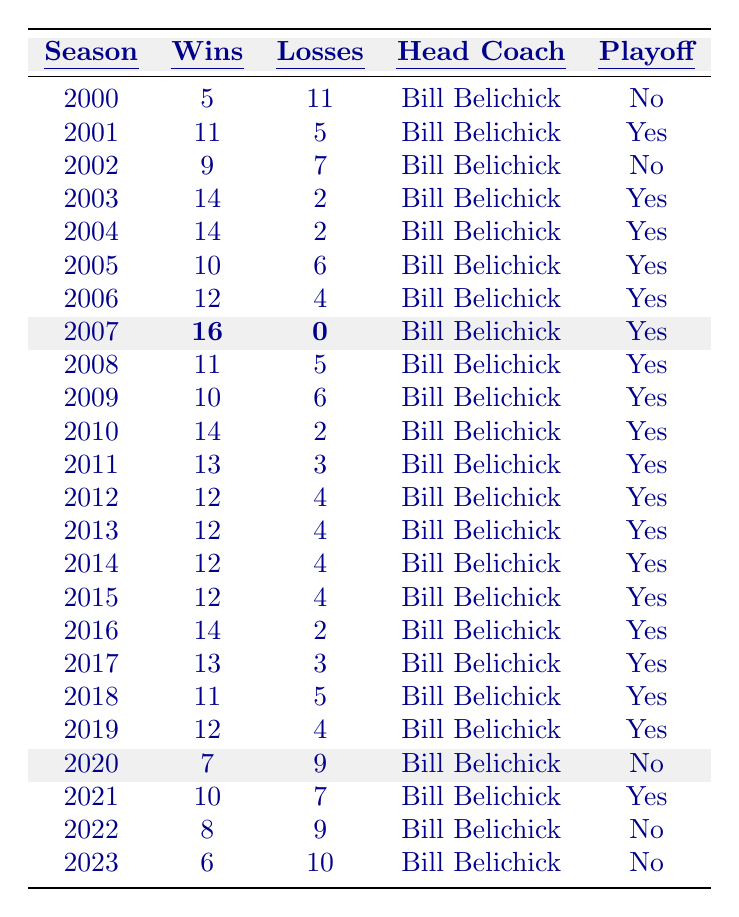What was the worst win-loss record for the Patriots during the 2000s? Reviewing the seasons from 2000 to 2009, the Patriots had their worst record in 2000 with 5 wins and 11 losses.
Answer: 5 wins, 11 losses How many seasons did the New England Patriots win 12 or more games? Counting the seasons where the wins are 12 or more, we find the following seasons: 2006, 2007, 2010, 2011, 2012, 2013, 2014, 2015, and 2016. This totals to 9 seasons.
Answer: 9 seasons Did the Patriots have a playoff appearance in 2021? The table indicates that the Patriots had 10 wins and 7 losses in 2021, and they did have a playoff appearance.
Answer: Yes What is the average number of wins for the Patriots from 2000 to 2023? Calculating the total wins: 5 + 11 + 9 + 14 + 14 + 10 + 12 + 16 + 11 + 10 + 14 + 13 + 12 + 12 + 12 + 12 + 14 + 13 + 11 + 12 + 7 + 10 + 8 + 6 = 217. With 24 seasons, the average is 217/24 = 9.04.
Answer: 9.04 How many seasons did the Patriots have a losing record (more losses than wins)? The losing records occur in 2000, 2002, 2020, 2022, and 2023. Counting these seasons gives us 5 losing seasons.
Answer: 5 seasons Which season had the most wins and how many did they win? The 2007 season had the most wins at 16, with no losses.
Answer: 16 wins When did the Patriots have back-to-back 14-win seasons? The Patriots achieved back-to-back 14-win seasons in 2003 and 2004.
Answer: 2003 and 2004 Were the Patriots consistent in making the playoffs during the 2010s? From the table, between 2010 to 2019, the Patriots had playoff appearances in most seasons except for 2019. This suggests a high level of consistency during the decade.
Answer: Yes What is the win-loss difference for the season with the highest number of wins? The highest wins were in 2007 with 16 wins and 0 losses, so the difference is 16 - 0 = 16.
Answer: 16 Did the Patriots' performance decline in 2020 compared to the previous season? In 2019, the Patriots had 12 wins and 4 losses, compared to 7 wins and 9 losses in 2020. This indicates a decline in performance.
Answer: Yes 